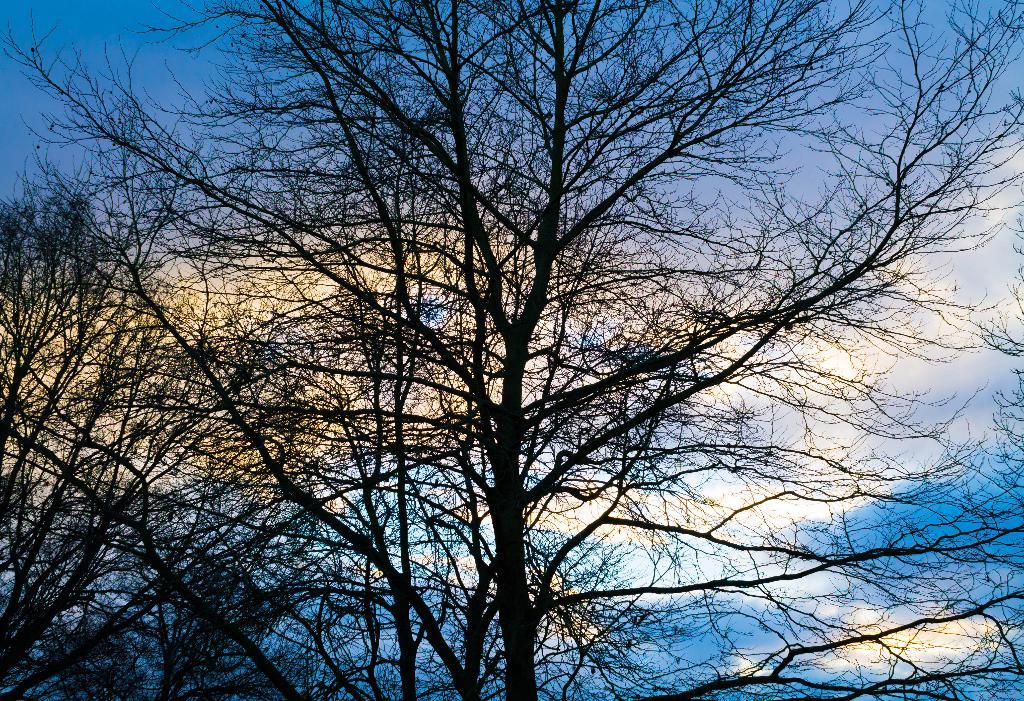What type of trees can be seen in the image? There are dried trees in the image. What is the condition of the trees in the image? The trees have no leaves. What color is the sky in the image? The sky is blue in color. Can you see any deer interacting with the trees in the image? There are no deer present in the image. What type of experience can be gained from observing the trees in the image? The image does not convey any specific experience; it simply shows dried trees with no leaves and a blue sky. 